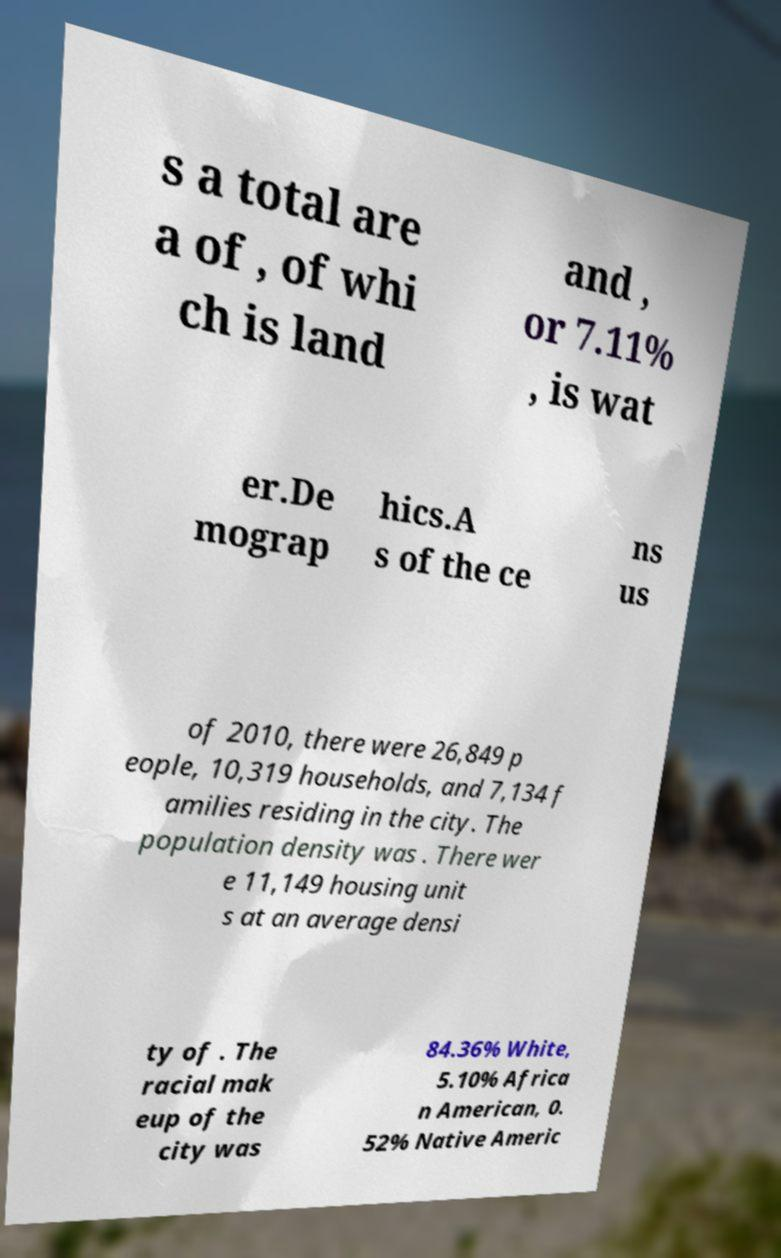Can you accurately transcribe the text from the provided image for me? s a total are a of , of whi ch is land and , or 7.11% , is wat er.De mograp hics.A s of the ce ns us of 2010, there were 26,849 p eople, 10,319 households, and 7,134 f amilies residing in the city. The population density was . There wer e 11,149 housing unit s at an average densi ty of . The racial mak eup of the city was 84.36% White, 5.10% Africa n American, 0. 52% Native Americ 